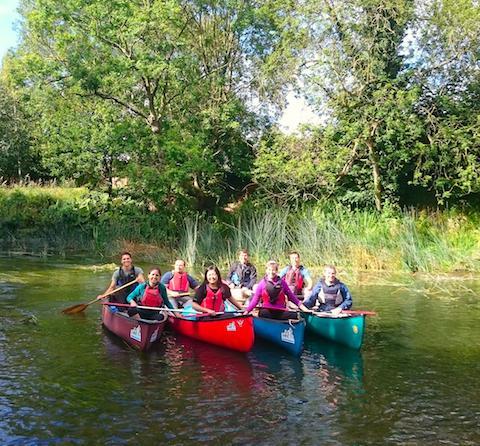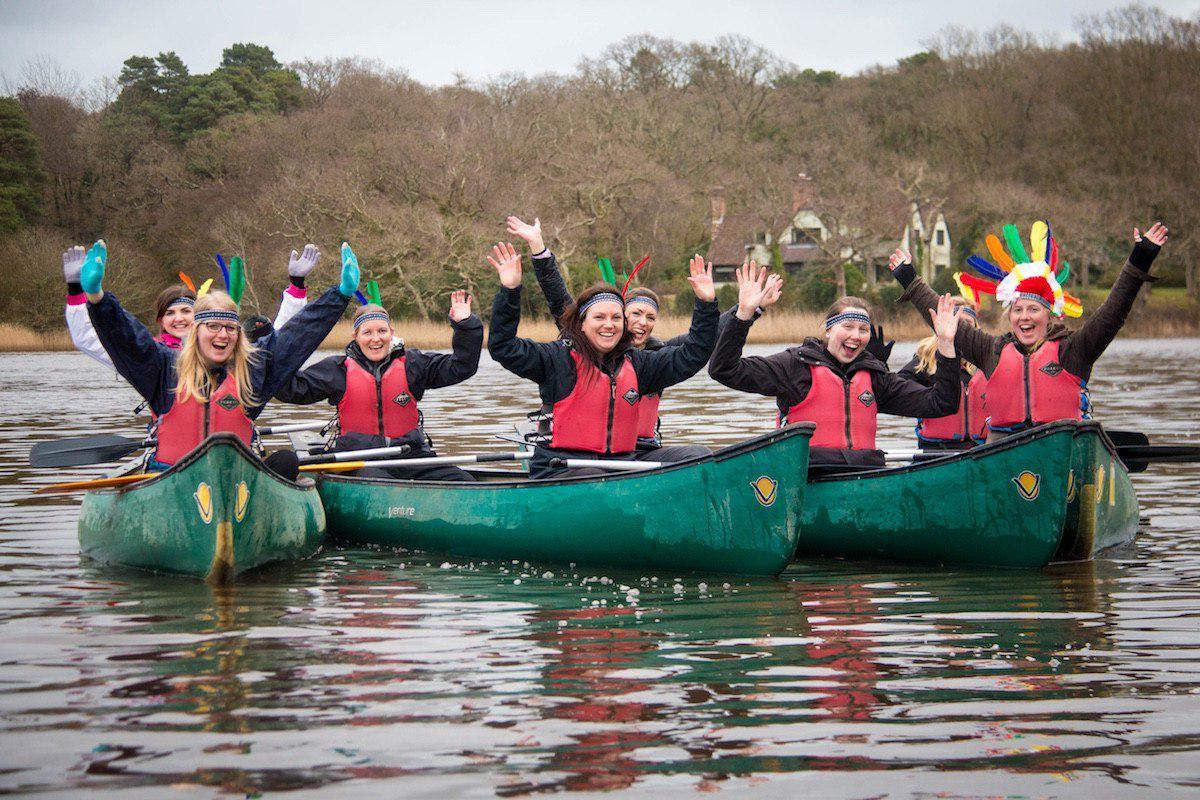The first image is the image on the left, the second image is the image on the right. Given the left and right images, does the statement "One image shows a row of forward-facing canoes featuring the same color and containing people with arms raised." hold true? Answer yes or no. Yes. The first image is the image on the left, the second image is the image on the right. For the images displayed, is the sentence "A group of people are in canoes with their hands in the air." factually correct? Answer yes or no. Yes. 